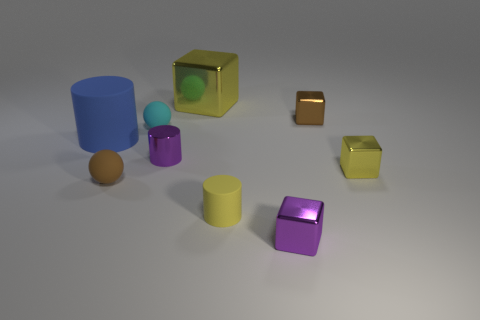Subtract all purple cylinders. How many cylinders are left? 2 Subtract all red cylinders. How many yellow cubes are left? 2 Subtract all cyan balls. How many balls are left? 1 Subtract all blocks. How many objects are left? 5 Subtract all gray cylinders. Subtract all purple blocks. How many cylinders are left? 3 Subtract all yellow objects. Subtract all big cyan rubber objects. How many objects are left? 6 Add 5 big yellow metallic cubes. How many big yellow metallic cubes are left? 6 Add 2 tiny purple blocks. How many tiny purple blocks exist? 3 Subtract 0 red cylinders. How many objects are left? 9 